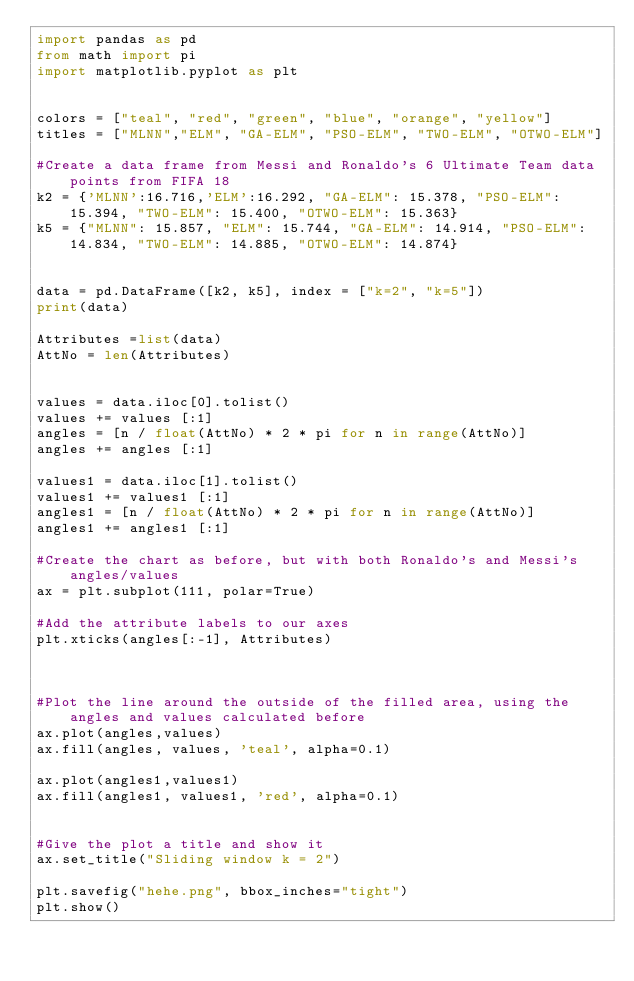Convert code to text. <code><loc_0><loc_0><loc_500><loc_500><_Python_>import pandas as pd
from math import pi
import matplotlib.pyplot as plt


colors = ["teal", "red", "green", "blue", "orange", "yellow"]
titles = ["MLNN","ELM", "GA-ELM", "PSO-ELM", "TWO-ELM", "OTWO-ELM"]

#Create a data frame from Messi and Ronaldo's 6 Ultimate Team data points from FIFA 18
k2 = {'MLNN':16.716,'ELM':16.292, "GA-ELM": 15.378, "PSO-ELM": 15.394, "TWO-ELM": 15.400, "OTWO-ELM": 15.363}
k5 = {"MLNN": 15.857, "ELM": 15.744, "GA-ELM": 14.914, "PSO-ELM": 14.834, "TWO-ELM": 14.885, "OTWO-ELM": 14.874}


data = pd.DataFrame([k2, k5], index = ["k=2", "k=5"])
print(data)

Attributes =list(data)
AttNo = len(Attributes)


values = data.iloc[0].tolist()
values += values [:1]
angles = [n / float(AttNo) * 2 * pi for n in range(AttNo)]
angles += angles [:1]

values1 = data.iloc[1].tolist()
values1 += values1 [:1]
angles1 = [n / float(AttNo) * 2 * pi for n in range(AttNo)]
angles1 += angles1 [:1]

#Create the chart as before, but with both Ronaldo's and Messi's angles/values
ax = plt.subplot(111, polar=True)

#Add the attribute labels to our axes
plt.xticks(angles[:-1], Attributes)



#Plot the line around the outside of the filled area, using the angles and values calculated before
ax.plot(angles,values)
ax.fill(angles, values, 'teal', alpha=0.1)

ax.plot(angles1,values1)
ax.fill(angles1, values1, 'red', alpha=0.1)


#Give the plot a title and show it
ax.set_title("Sliding window k = 2")

plt.savefig("hehe.png", bbox_inches="tight")
plt.show()


</code> 